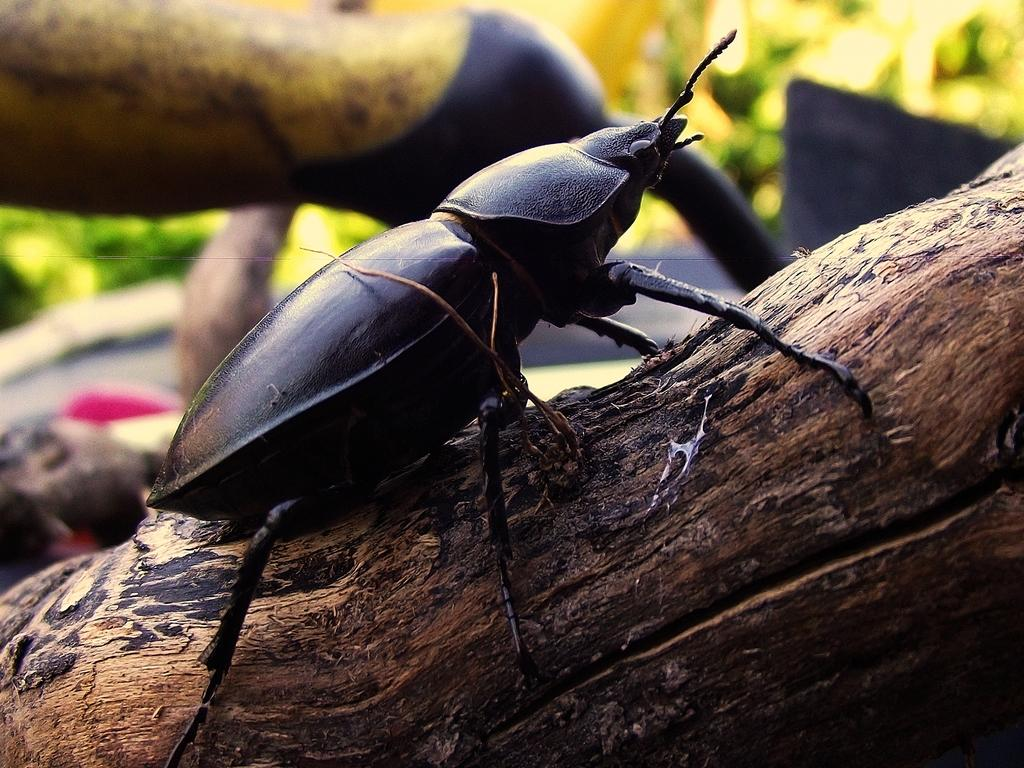What is the main object in the image? There is a tree log in the image. What else can be seen in the image besides the tree log? There is an insect in the image. Can you describe the insect? The insect is black in color, has legs, and has antenna. What is visible in the background of the image? There are plants visible in the background, but they are not clearly visible. What type of skin condition does the insect have in the image? There is no indication of a skin condition on the insect in the image, as insects do not have skin like humans or mammals. 